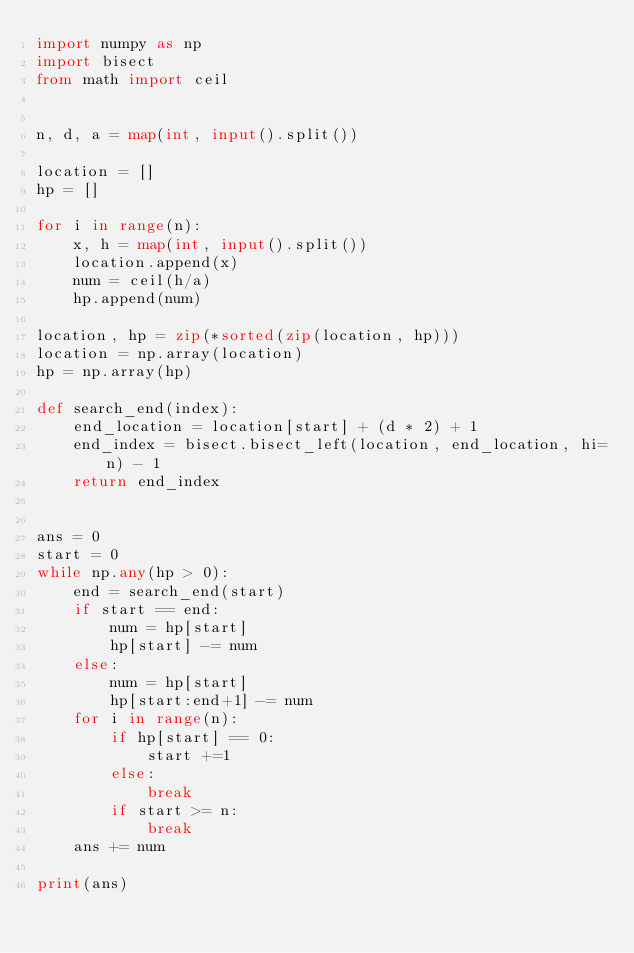Convert code to text. <code><loc_0><loc_0><loc_500><loc_500><_Python_>import numpy as np
import bisect
from math import ceil


n, d, a = map(int, input().split())

location = []
hp = []

for i in range(n):
    x, h = map(int, input().split())
    location.append(x)
    num = ceil(h/a)
    hp.append(num)

location, hp = zip(*sorted(zip(location, hp)))
location = np.array(location)
hp = np.array(hp)

def search_end(index):
    end_location = location[start] + (d * 2) + 1
    end_index = bisect.bisect_left(location, end_location, hi=n) - 1
    return end_index


ans = 0
start = 0
while np.any(hp > 0):
    end = search_end(start)
    if start == end:
        num = hp[start]
        hp[start] -= num
    else:
        num = hp[start]
        hp[start:end+1] -= num
    for i in range(n):
        if hp[start] == 0:
            start +=1
        else:
            break
        if start >= n:
            break
    ans += num

print(ans)


</code> 